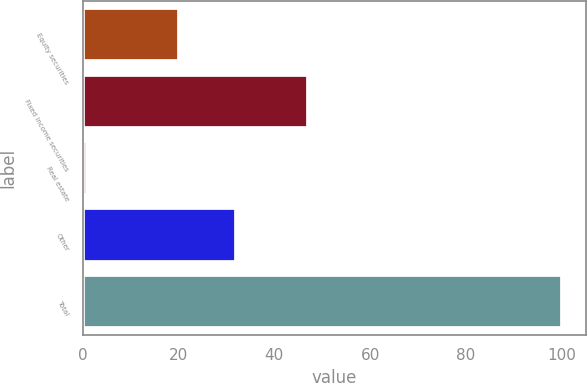<chart> <loc_0><loc_0><loc_500><loc_500><bar_chart><fcel>Equity securities<fcel>Fixed income securities<fcel>Real estate<fcel>Other<fcel>Total<nl><fcel>20<fcel>47<fcel>1<fcel>32<fcel>100<nl></chart> 